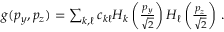<formula> <loc_0><loc_0><loc_500><loc_500>\begin{array} { r } { g ( p _ { y } , p _ { z } ) = \sum _ { k , \ell } c _ { k \ell } H _ { k } \left ( \frac { p _ { y } } { \sqrt { 2 } } \right ) H _ { \ell } \left ( \frac { p _ { z } } { \sqrt { 2 } } \right ) \, . } \end{array}</formula> 